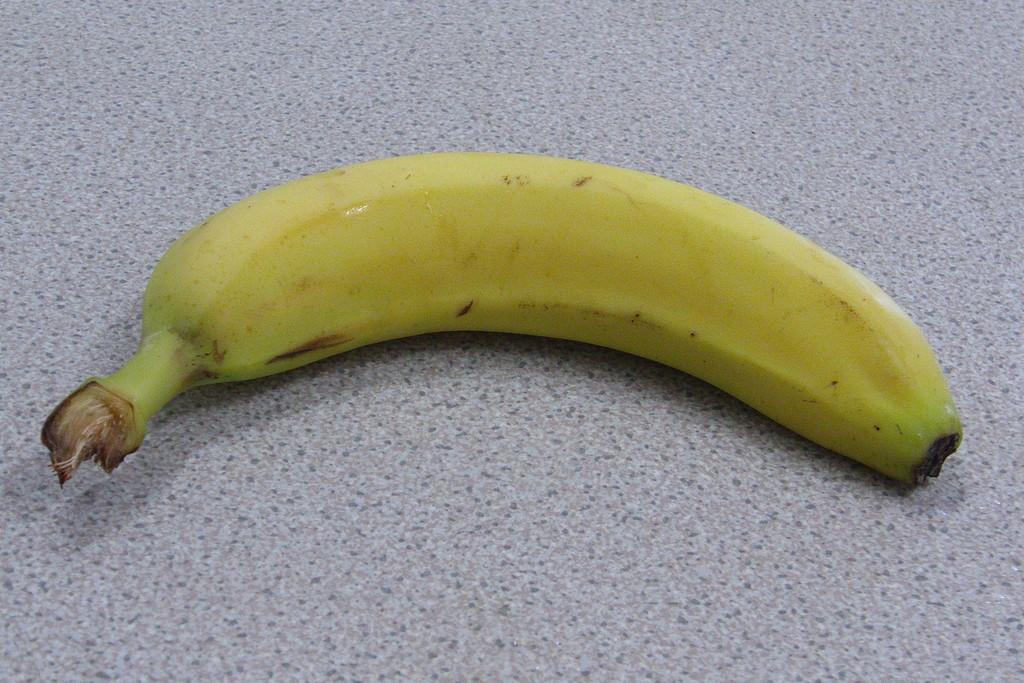Could you give a brief overview of what you see in this image? In the center of the image we can see a banana placed on the surface. 